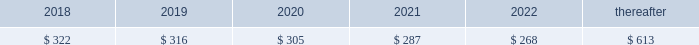92 | 2017 form 10-k finite-lived intangible assets are amortized over their estimated useful lives and tested for impairment if events or changes in circumstances indicate that the asset may be impaired .
In 2016 , gross customer relationship intangibles of $ 96 million and related accumulated amortization of $ 27 million as well as gross intellectual property intangibles of $ 111 million and related accumulated amortization of $ 48 million from the resource industries segment were impaired .
The fair value of these intangibles was determined to be insignificant based on an income approach using expected cash flows .
The fair value determination is categorized as level 3 in the fair value hierarchy due to its use of internal projections and unobservable measurement inputs .
The total impairment of $ 132 million was a result of restructuring activities and is included in other operating ( income ) expense in statement 1 .
See note 25 for information on restructuring costs .
Amortization expense related to intangible assets was $ 323 million , $ 326 million and $ 337 million for 2017 , 2016 and 2015 , respectively .
As of december 31 , 2017 , amortization expense related to intangible assets is expected to be : ( millions of dollars ) .
Goodwill there were no goodwill impairments during 2017 or 2015 .
Our annual impairment tests completed in the fourth quarter of 2016 indicated the fair value of each reporting unit was substantially above its respective carrying value , including goodwill , with the exception of our surface mining & technology reporting unit .
The surface mining & technology reporting unit , which primarily serves the mining industry , is a part of our resource industries segment .
The goodwill assigned to this reporting unit is largely from our acquisition of bucyrus international , inc .
In 2011 .
Its product portfolio includes large mining trucks , electric rope shovels , draglines , hydraulic shovels and related parts .
In addition to equipment , surface mining & technology also develops and sells technology products and services to provide customer fleet management , equipment management analytics and autonomous machine capabilities .
The annual impairment test completed in the fourth quarter of 2016 indicated that the fair value of surface mining & technology was below its carrying value requiring the second step of the goodwill impairment test process .
The fair value of surface mining & technology was determined primarily using an income approach based on a discounted ten year cash flow .
We assigned the fair value to surface mining & technology 2019s assets and liabilities using various valuation techniques that required assumptions about royalty rates , dealer attrition , technological obsolescence and discount rates .
The resulting implied fair value of goodwill was below the carrying value .
Accordingly , we recognized a goodwill impairment charge of $ 595 million , which resulted in goodwill of $ 629 million remaining for surface mining & technology as of october 1 , 2016 .
The fair value determination is categorized as level 3 in the fair value hierarchy due to its use of internal projections and unobservable measurement inputs .
There was a $ 17 million tax benefit associated with this impairment charge. .
What is the expected growth rate in amortization expense in 2019? 
Computations: ((316 - 322) / 322)
Answer: -0.01863. 